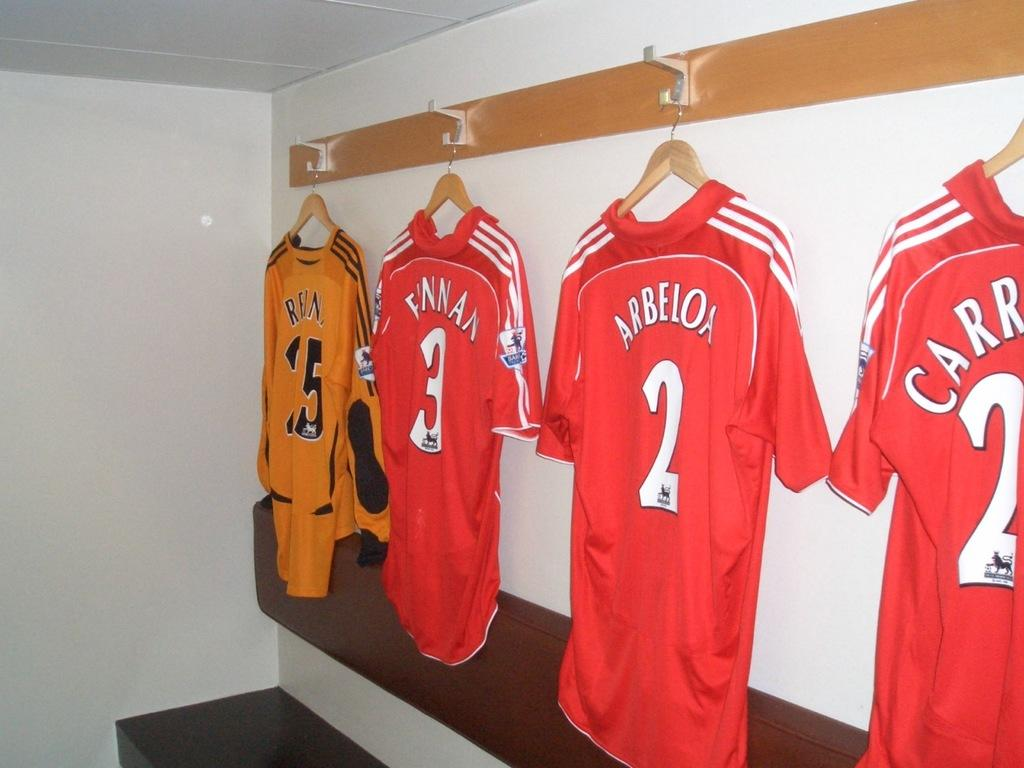<image>
Render a clear and concise summary of the photo. Several sports jerseys are hanging up in a room and one of them says Arbeloa. 